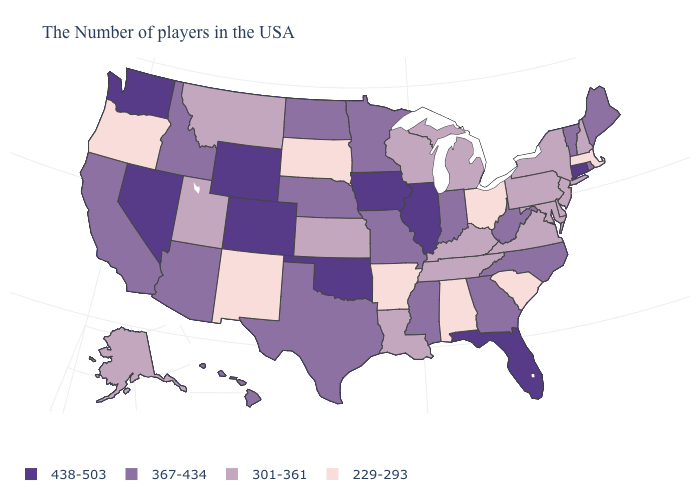Name the states that have a value in the range 301-361?
Answer briefly. New Hampshire, New York, New Jersey, Delaware, Maryland, Pennsylvania, Virginia, Michigan, Kentucky, Tennessee, Wisconsin, Louisiana, Kansas, Utah, Montana, Alaska. Is the legend a continuous bar?
Be succinct. No. What is the value of Alaska?
Be succinct. 301-361. Name the states that have a value in the range 301-361?
Short answer required. New Hampshire, New York, New Jersey, Delaware, Maryland, Pennsylvania, Virginia, Michigan, Kentucky, Tennessee, Wisconsin, Louisiana, Kansas, Utah, Montana, Alaska. What is the value of Iowa?
Short answer required. 438-503. Name the states that have a value in the range 367-434?
Be succinct. Maine, Rhode Island, Vermont, North Carolina, West Virginia, Georgia, Indiana, Mississippi, Missouri, Minnesota, Nebraska, Texas, North Dakota, Arizona, Idaho, California, Hawaii. Does the map have missing data?
Concise answer only. No. What is the highest value in the MidWest ?
Write a very short answer. 438-503. What is the value of Connecticut?
Write a very short answer. 438-503. Name the states that have a value in the range 229-293?
Concise answer only. Massachusetts, South Carolina, Ohio, Alabama, Arkansas, South Dakota, New Mexico, Oregon. Among the states that border Florida , which have the highest value?
Short answer required. Georgia. Name the states that have a value in the range 229-293?
Be succinct. Massachusetts, South Carolina, Ohio, Alabama, Arkansas, South Dakota, New Mexico, Oregon. What is the lowest value in the West?
Give a very brief answer. 229-293. Name the states that have a value in the range 229-293?
Be succinct. Massachusetts, South Carolina, Ohio, Alabama, Arkansas, South Dakota, New Mexico, Oregon. Name the states that have a value in the range 367-434?
Concise answer only. Maine, Rhode Island, Vermont, North Carolina, West Virginia, Georgia, Indiana, Mississippi, Missouri, Minnesota, Nebraska, Texas, North Dakota, Arizona, Idaho, California, Hawaii. 